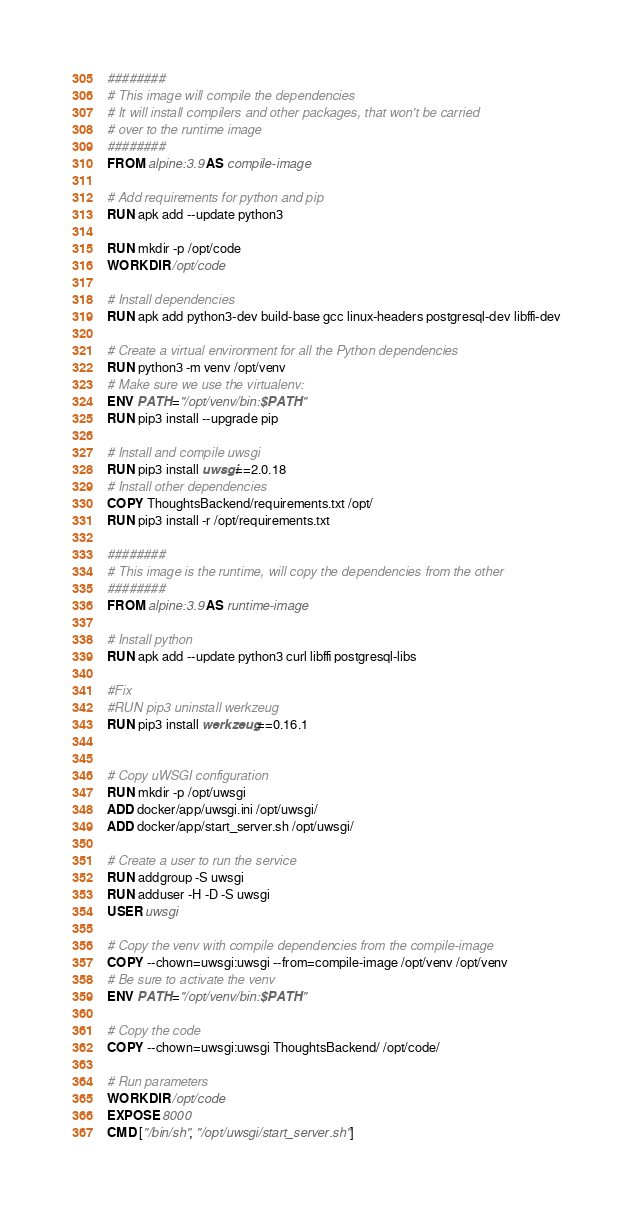Convert code to text. <code><loc_0><loc_0><loc_500><loc_500><_Dockerfile_>########
# This image will compile the dependencies
# It will install compilers and other packages, that won't be carried
# over to the runtime image
########
FROM alpine:3.9 AS compile-image

# Add requirements for python and pip
RUN apk add --update python3

RUN mkdir -p /opt/code
WORKDIR /opt/code

# Install dependencies
RUN apk add python3-dev build-base gcc linux-headers postgresql-dev libffi-dev

# Create a virtual environment for all the Python dependencies
RUN python3 -m venv /opt/venv
# Make sure we use the virtualenv:
ENV PATH="/opt/venv/bin:$PATH"
RUN pip3 install --upgrade pip

# Install and compile uwsgi
RUN pip3 install uwsgi==2.0.18
# Install other dependencies
COPY ThoughtsBackend/requirements.txt /opt/
RUN pip3 install -r /opt/requirements.txt

########
# This image is the runtime, will copy the dependencies from the other
########
FROM alpine:3.9 AS runtime-image

# Install python
RUN apk add --update python3 curl libffi postgresql-libs

#Fix
#RUN pip3 uninstall werkzeug
RUN pip3 install werkzeug==0.16.1


# Copy uWSGI configuration
RUN mkdir -p /opt/uwsgi
ADD docker/app/uwsgi.ini /opt/uwsgi/
ADD docker/app/start_server.sh /opt/uwsgi/

# Create a user to run the service
RUN addgroup -S uwsgi
RUN adduser -H -D -S uwsgi
USER uwsgi

# Copy the venv with compile dependencies from the compile-image
COPY --chown=uwsgi:uwsgi --from=compile-image /opt/venv /opt/venv
# Be sure to activate the venv
ENV PATH="/opt/venv/bin:$PATH"

# Copy the code
COPY --chown=uwsgi:uwsgi ThoughtsBackend/ /opt/code/

# Run parameters
WORKDIR /opt/code
EXPOSE 8000
CMD ["/bin/sh", "/opt/uwsgi/start_server.sh"]
</code> 